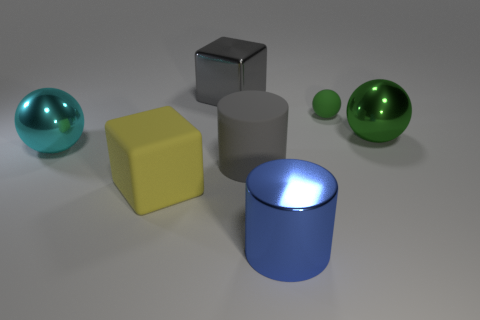What is the material of the big cube that is the same color as the large rubber cylinder?
Make the answer very short. Metal. Is there a large thing that has the same color as the matte sphere?
Provide a succinct answer. Yes. Does the big shiny block have the same color as the large rubber cylinder?
Offer a very short reply. Yes. How many other objects are there of the same color as the rubber cylinder?
Your answer should be compact. 1. There is a big object right of the shiny object in front of the large metallic thing that is to the left of the big metal cube; what is it made of?
Provide a short and direct response. Metal. What material is the large thing behind the green metal thing?
Keep it short and to the point. Metal. Is there a cyan shiny sphere of the same size as the cyan metallic thing?
Provide a succinct answer. No. Do the big metal ball right of the green matte object and the rubber sphere have the same color?
Make the answer very short. Yes. What number of cyan objects are either metallic cylinders or large cubes?
Make the answer very short. 0. How many small rubber spheres have the same color as the tiny matte thing?
Provide a succinct answer. 0. 